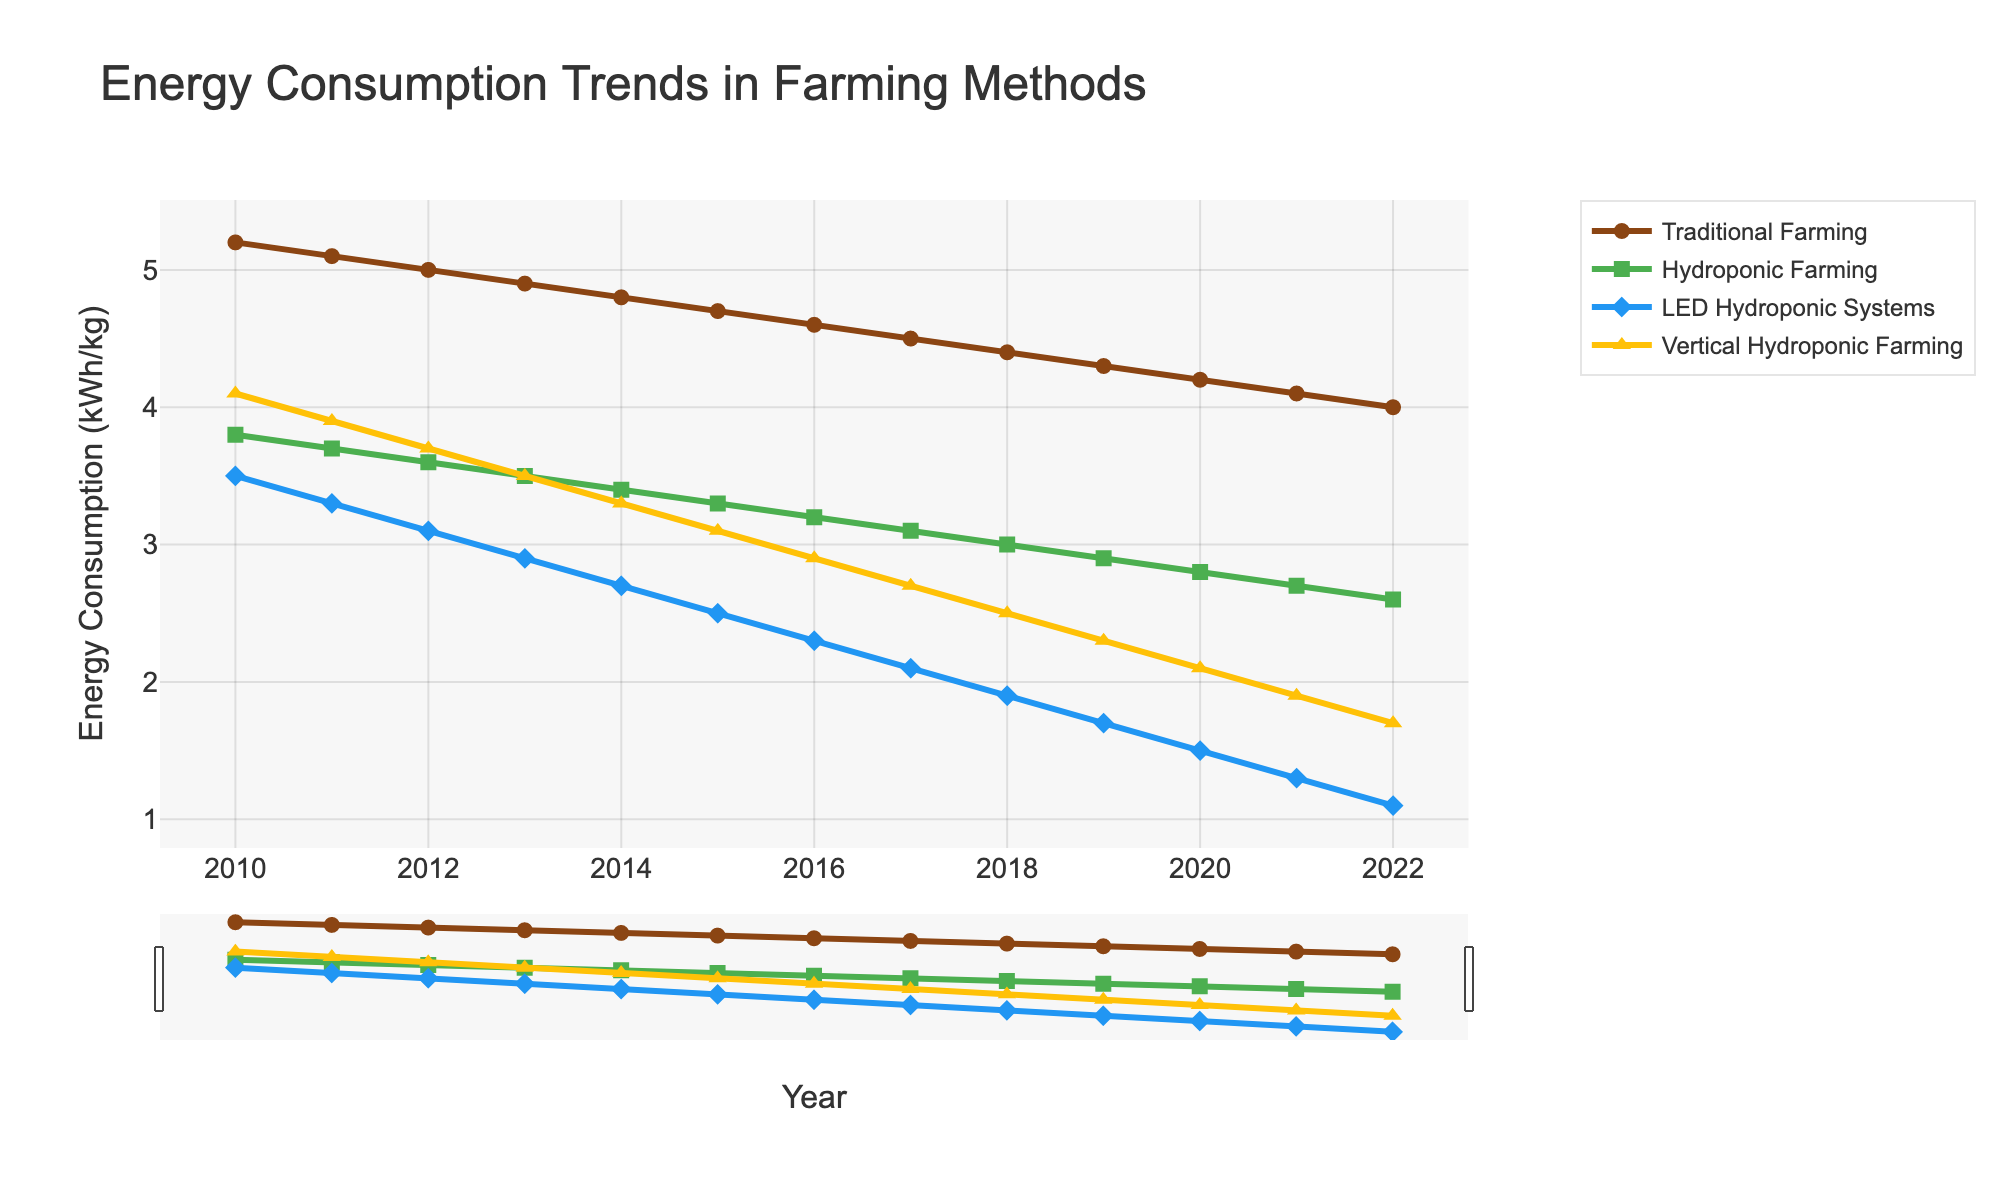What's the trend of energy consumption in traditional farming from 2010 to 2022? Observe the brown line for traditional farming from 2010 to 2022. The line consistently declines each year, indicating a decreasing trend in energy consumption.
Answer: Decreasing In which year did LED hydroponic systems start to consume less energy than traditional farming? Look at the points where the blue line (LED Hydroponic Systems) intersects below the brown line (Traditional Farming). The intersection occurs between 2010 and 2012, establishing 2012 as the first year LED hydroponics consumed less energy than traditional farming.
Answer: 2012 How does the energy consumption of vertical hydroponic farming in 2022 compare to hydroponic farming in the same year? Identify the values at 2022 for both vertical hydroponic farming (yellow line) and hydroponic farming (green line). Vertical hydroponic farming is at 1.7 kWh/kg, while hydroponic farming is at 2.6 kWh/kg, making vertical hydroponic farming more energy-efficient by 0.9 kWh/kg.
Answer: Vertical hydroponic farming is more energy-efficient by 0.9 kWh/kg What is the average annual energy consumption of LED hydroponic systems from 2010 to 2022? Identify the values of LED hydroponic systems from 2010 to 2022: [3.5, 3.3, 3.1, 2.9, 2.7, 2.5, 2.3, 2.1, 1.9, 1.7, 1.5, 1.3, 1.1]. Sum these values to get 30.9, then divide by 13 (number of years) to find the average: 30.9/13 ≈ 2.38 kWh/kg.
Answer: 2.38 kWh/kg Which farming method shows the steepest decline in energy consumption over the years? Compare the slopes of the lines representing different farming methods. The blue line for LED Hydroponic Systems shows the steepest decline from 3.5 kWh/kg in 2010 to 1.1 kWh/kg in 2022.
Answer: LED Hydroponic Systems During which years did traditional farming consume more than double the energy of LED hydroponic systems? Look at the difference between the brown line (Traditional Farming) and the blue line (LED Hydroponic Systems). For double the energy: Traditional Farming > 2 * LED Hydroponic Systems. In 2010-2013, Traditional farming values were 5.2, 5.1, 5.0, 4.9 compared to LED values of 3.5, 3.3, 3.1, 2.9. Calculate if traditional farming values are more than twice that of LED values. (e.g., in 2010: 5.2 is more than 2*3.5).
Answer: 2010-2012 What is the difference in energy consumption between hydroponic farming and vertical hydroponic farming in 2015? Identify the values at 2015 for hydroponic farming (green line) and vertical hydroponic farming (yellow line). Hydroponic farming is at 3.3 kWh/kg whereas vertical hydroponic farming is at 3.1 kWh/kg. The difference is 3.3 - 3.1 = 0.2 kWh/kg.
Answer: 0.2 kWh/kg How does the rate of decline in energy consumption in traditional farming compare to hydroponic farming between 2010 and 2022? Calculate the rate of decline for both methods. Traditional farming declines from 5.2 kWh/kg in 2010 to 4.0 kWh/kg in 2022, a drop of 1.2 kWh/kg over 12 years (approx. 0.1 kWh/kg per year). Hydroponic farming declines from 3.8 to 2.6 kWh/kg, a drop of 1.2 kWh/kg over 12 years (approx. 0.1 kWh/kg per year).
Answer: Same rate of decline In 2015, which farming method had the lowest energy consumption, and what was its value? Locate the year 2015 on the x-axis and identify the lowest y-value among all farming methods. The blue line (LED Hydroponic Systems) is the lowest at 2.5 kWh/kg.
Answer: LED Hydroponic Systems, 2.5 kWh/kg 